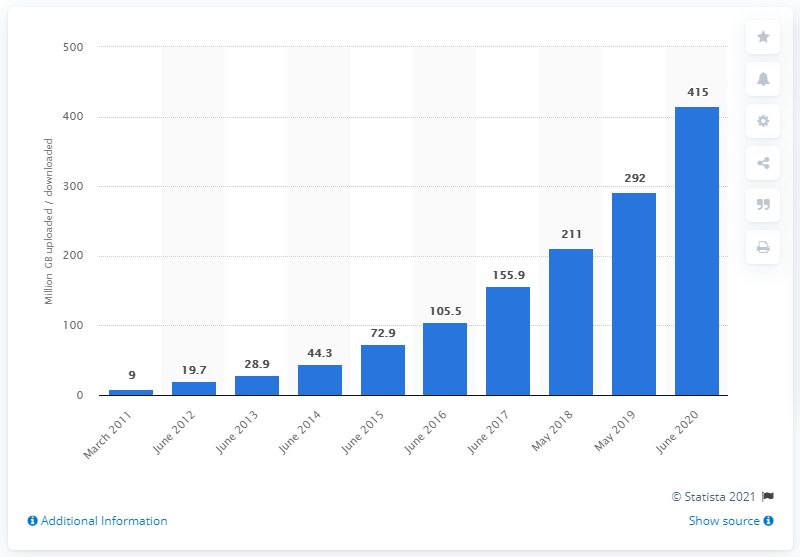List a handful of essential elements in this visual. In June 2020, the total amount of mobile data traffic in the UK was 415... 